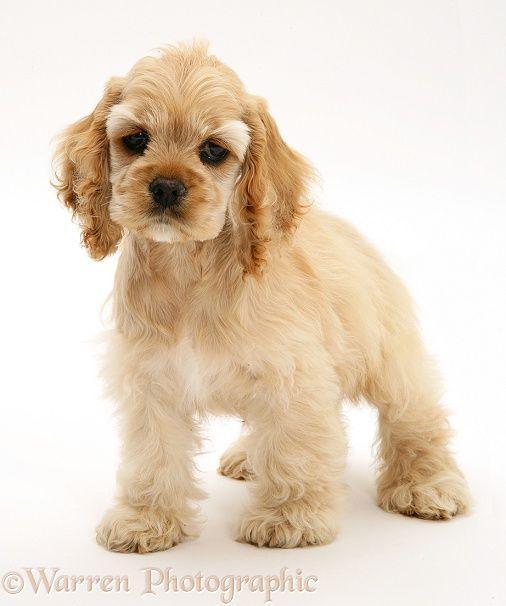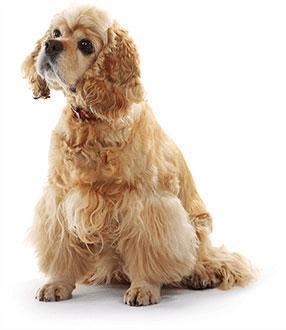The first image is the image on the left, the second image is the image on the right. Examine the images to the left and right. Is the description "There are two dogs standing and facing left." accurate? Answer yes or no. No. 